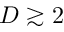Convert formula to latex. <formula><loc_0><loc_0><loc_500><loc_500>D \gtrsim 2</formula> 